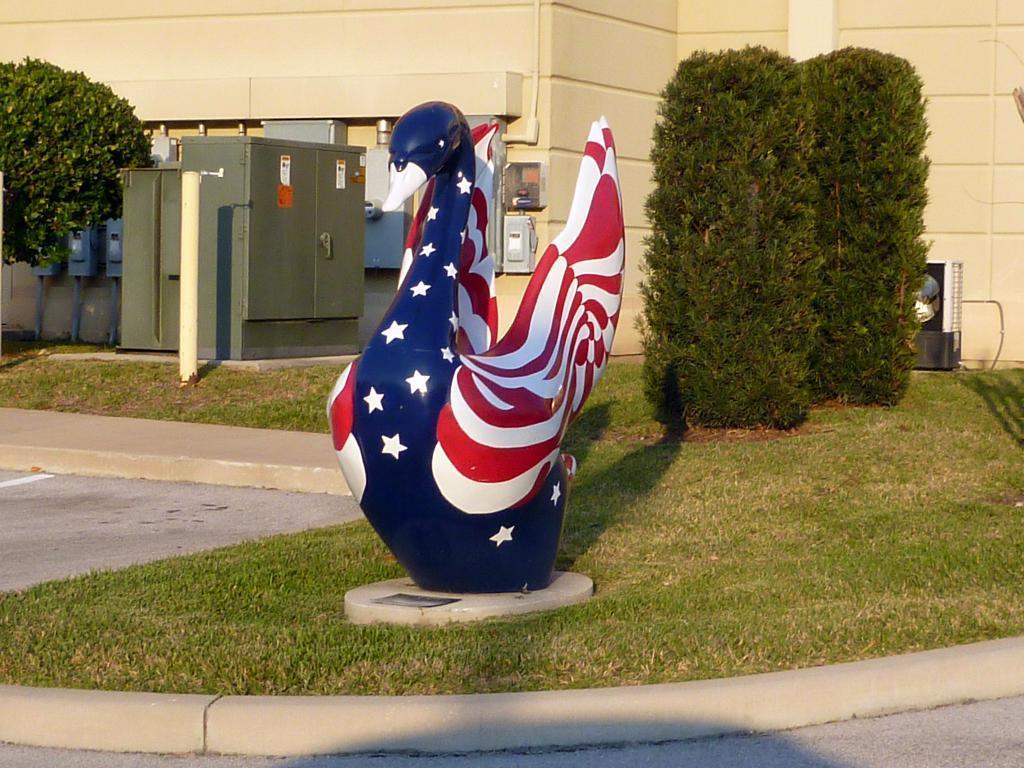Please provide a concise description of this image. In the center of the image we can see a statue of a duck. In the background there is a building, generator, switch boards, plants and trees. 